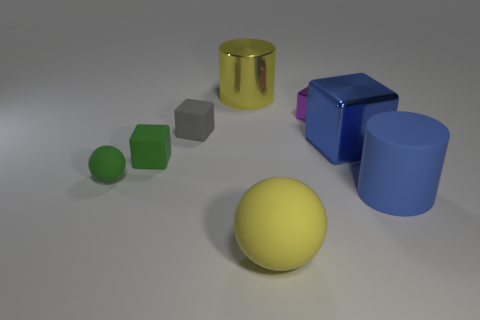Add 2 green rubber spheres. How many objects exist? 10 Subtract all small blocks. How many blocks are left? 1 Subtract all green blocks. How many blocks are left? 3 Subtract 1 cubes. How many cubes are left? 3 Add 8 blue cubes. How many blue cubes exist? 9 Subtract 0 brown cylinders. How many objects are left? 8 Subtract all gray spheres. Subtract all purple cylinders. How many spheres are left? 2 Subtract all large red shiny cubes. Subtract all big objects. How many objects are left? 4 Add 7 purple objects. How many purple objects are left? 8 